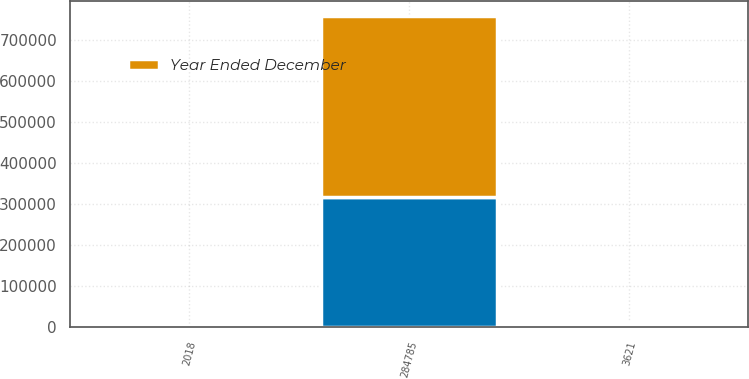Convert chart. <chart><loc_0><loc_0><loc_500><loc_500><stacked_bar_chart><ecel><fcel>2018<fcel>284785<fcel>3621<nl><fcel>nan<fcel>2017<fcel>317515<fcel>3901<nl><fcel>Year Ended December<fcel>2016<fcel>439667<fcel>5464<nl></chart> 